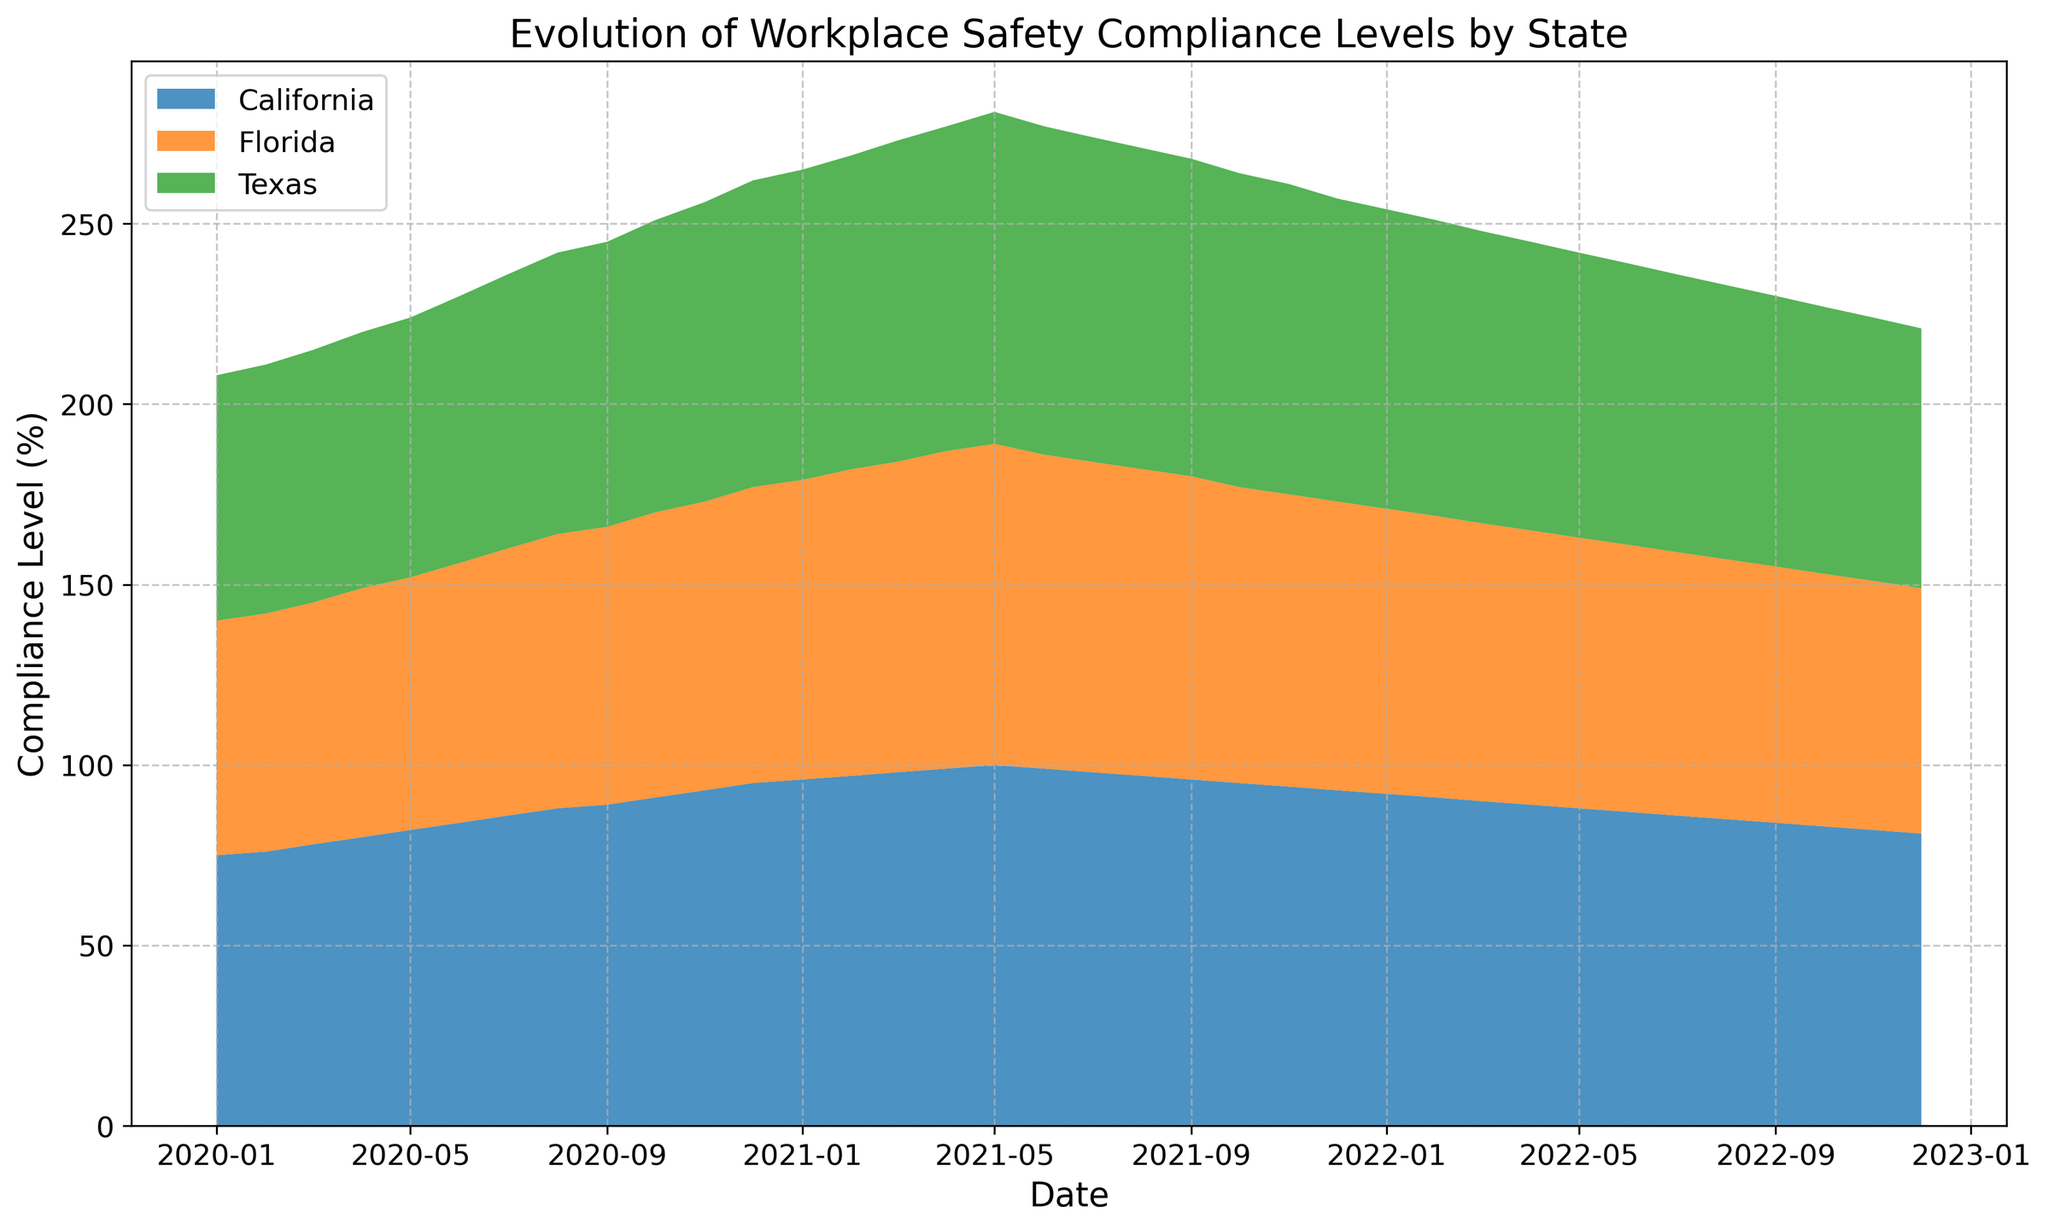What is the general trend of compliance levels for California from January 2020 to December 2022? The compliance level in California generally increases from 75% in January 2020, reaches a peak of 100% around mid-2021, and then gradually decreases to 81% by December 2022.
Answer: Increases then decreases How do the compliance levels of Texas and Florida compare in December 2022? In December 2022, Texas has a compliance level of 72%, while Florida has a compliance level of 68%.
Answer: Texas is higher than Florida Which state reached the maximum compliance level first, and in which month? California first reached the maximum compliance level of 100% in May 2021.
Answer: California in May 2021 On average, by how many percentage points did Florida’s compliance level change per month from January 2020 to December 2022? The total change in Florida's compliance level from January 2020 (65%) to December 2022 (68%) is 68 - 65 = 3 percentage points. Over 36 months, the average monthly change is 3 / 36 ≈ 0.083 percentage points.
Answer: Approximately 0.083 percentage points per month What was the difference in compliance levels between California and Texas in January 2021? In January 2021, California had a compliance level of 96% and Texas had 86%. The difference is 96 - 86 = 10 percentage points.
Answer: 10 percentage points By how much did the compliance level of California drop between its peak and December 2022? California peaked at 100% in May 2021 and dropped to 81% in December 2022. The drop is 100 - 81 = 19 percentage points.
Answer: 19 percentage points Which state showed the most consistency in compliance levels over the observed period? By observing the plot, Florida shows a relatively consistent and gradual increase and decrease without sudden jumps compared to the other states.
Answer: Florida What is the ratio of compliance level of California to Florida in March 2021? In March 2021, California's compliance level was 98% and Florida's was 86%. The ratio is 98 / 86 ≈ 1.14.
Answer: Approximately 1.14 Is there any month within the observed period where all three states had the same compliance level? Reviewing the plot, it is clear that at no point did California, Texas, and Florida have the same compliance levels.
Answer: No Which state had the highest compliance level in July 2022? In July 2022, California leads with the highest compliance level compared to Texas and Florida.
Answer: California 